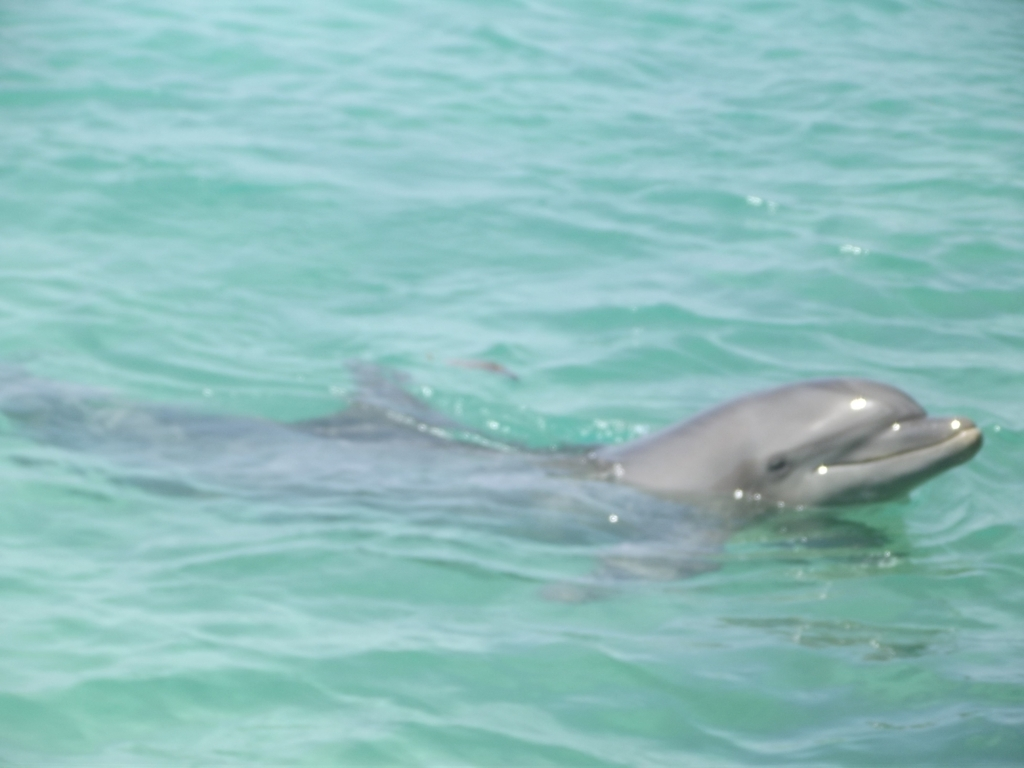Can you infer anything about the behavior of this dolphin from the image? It's difficult to infer behavior from a single still image. However, the dolphin's posture near the surface and its proximity to the camera might suggest it is exhibiting curiosity or social behavior, which are common traits among dolphins. 